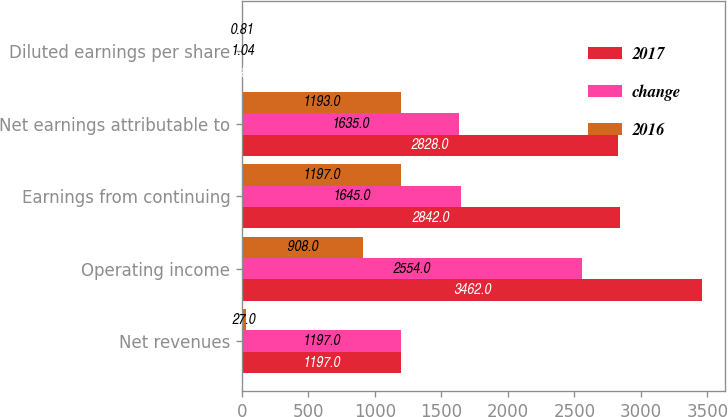Convert chart. <chart><loc_0><loc_0><loc_500><loc_500><stacked_bar_chart><ecel><fcel>Net revenues<fcel>Operating income<fcel>Earnings from continuing<fcel>Net earnings attributable to<fcel>Diluted earnings per share<nl><fcel>2017<fcel>1197<fcel>3462<fcel>2842<fcel>2828<fcel>1.85<nl><fcel>change<fcel>1197<fcel>2554<fcel>1645<fcel>1635<fcel>1.04<nl><fcel>2016<fcel>27<fcel>908<fcel>1197<fcel>1193<fcel>0.81<nl></chart> 